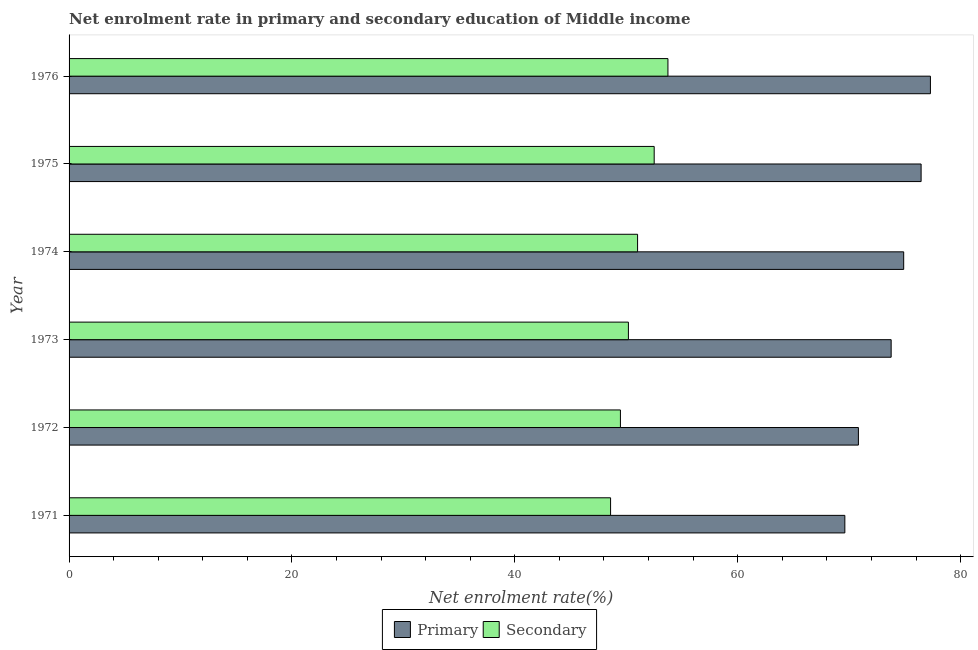How many different coloured bars are there?
Keep it short and to the point. 2. Are the number of bars per tick equal to the number of legend labels?
Your answer should be very brief. Yes. Are the number of bars on each tick of the Y-axis equal?
Provide a short and direct response. Yes. How many bars are there on the 2nd tick from the bottom?
Keep it short and to the point. 2. What is the label of the 3rd group of bars from the top?
Offer a very short reply. 1974. In how many cases, is the number of bars for a given year not equal to the number of legend labels?
Make the answer very short. 0. What is the enrollment rate in secondary education in 1971?
Ensure brevity in your answer.  48.59. Across all years, what is the maximum enrollment rate in secondary education?
Your response must be concise. 53.74. Across all years, what is the minimum enrollment rate in primary education?
Your answer should be very brief. 69.61. In which year was the enrollment rate in primary education maximum?
Give a very brief answer. 1976. What is the total enrollment rate in secondary education in the graph?
Offer a very short reply. 305.52. What is the difference between the enrollment rate in primary education in 1974 and that in 1975?
Offer a terse response. -1.56. What is the difference between the enrollment rate in secondary education in 1971 and the enrollment rate in primary education in 1973?
Your answer should be compact. -25.18. What is the average enrollment rate in secondary education per year?
Offer a terse response. 50.92. In the year 1976, what is the difference between the enrollment rate in secondary education and enrollment rate in primary education?
Provide a succinct answer. -23.55. In how many years, is the enrollment rate in primary education greater than 76 %?
Provide a short and direct response. 2. What is the ratio of the enrollment rate in primary education in 1971 to that in 1974?
Your response must be concise. 0.93. Is the enrollment rate in secondary education in 1975 less than that in 1976?
Offer a very short reply. Yes. Is the difference between the enrollment rate in primary education in 1971 and 1976 greater than the difference between the enrollment rate in secondary education in 1971 and 1976?
Your response must be concise. No. What is the difference between the highest and the second highest enrollment rate in primary education?
Offer a very short reply. 0.83. What is the difference between the highest and the lowest enrollment rate in secondary education?
Provide a succinct answer. 5.15. Is the sum of the enrollment rate in primary education in 1974 and 1976 greater than the maximum enrollment rate in secondary education across all years?
Make the answer very short. Yes. What does the 1st bar from the top in 1975 represents?
Offer a terse response. Secondary. What does the 1st bar from the bottom in 1974 represents?
Make the answer very short. Primary. Are all the bars in the graph horizontal?
Keep it short and to the point. Yes. How many years are there in the graph?
Your response must be concise. 6. Does the graph contain grids?
Make the answer very short. No. Where does the legend appear in the graph?
Your answer should be very brief. Bottom center. How many legend labels are there?
Your response must be concise. 2. What is the title of the graph?
Provide a short and direct response. Net enrolment rate in primary and secondary education of Middle income. What is the label or title of the X-axis?
Provide a succinct answer. Net enrolment rate(%). What is the Net enrolment rate(%) of Primary in 1971?
Your response must be concise. 69.61. What is the Net enrolment rate(%) of Secondary in 1971?
Provide a short and direct response. 48.59. What is the Net enrolment rate(%) of Primary in 1972?
Keep it short and to the point. 70.83. What is the Net enrolment rate(%) of Secondary in 1972?
Make the answer very short. 49.48. What is the Net enrolment rate(%) in Primary in 1973?
Offer a terse response. 73.77. What is the Net enrolment rate(%) of Secondary in 1973?
Offer a very short reply. 50.19. What is the Net enrolment rate(%) of Primary in 1974?
Your answer should be compact. 74.9. What is the Net enrolment rate(%) of Secondary in 1974?
Give a very brief answer. 51.02. What is the Net enrolment rate(%) in Primary in 1975?
Provide a succinct answer. 76.46. What is the Net enrolment rate(%) of Secondary in 1975?
Make the answer very short. 52.51. What is the Net enrolment rate(%) in Primary in 1976?
Offer a very short reply. 77.29. What is the Net enrolment rate(%) in Secondary in 1976?
Provide a short and direct response. 53.74. Across all years, what is the maximum Net enrolment rate(%) of Primary?
Provide a succinct answer. 77.29. Across all years, what is the maximum Net enrolment rate(%) in Secondary?
Your response must be concise. 53.74. Across all years, what is the minimum Net enrolment rate(%) of Primary?
Ensure brevity in your answer.  69.61. Across all years, what is the minimum Net enrolment rate(%) of Secondary?
Your answer should be very brief. 48.59. What is the total Net enrolment rate(%) of Primary in the graph?
Ensure brevity in your answer.  442.87. What is the total Net enrolment rate(%) of Secondary in the graph?
Your answer should be very brief. 305.52. What is the difference between the Net enrolment rate(%) in Primary in 1971 and that in 1972?
Ensure brevity in your answer.  -1.22. What is the difference between the Net enrolment rate(%) of Secondary in 1971 and that in 1972?
Ensure brevity in your answer.  -0.88. What is the difference between the Net enrolment rate(%) in Primary in 1971 and that in 1973?
Make the answer very short. -4.16. What is the difference between the Net enrolment rate(%) of Secondary in 1971 and that in 1973?
Make the answer very short. -1.6. What is the difference between the Net enrolment rate(%) in Primary in 1971 and that in 1974?
Offer a very short reply. -5.28. What is the difference between the Net enrolment rate(%) in Secondary in 1971 and that in 1974?
Keep it short and to the point. -2.42. What is the difference between the Net enrolment rate(%) in Primary in 1971 and that in 1975?
Give a very brief answer. -6.84. What is the difference between the Net enrolment rate(%) in Secondary in 1971 and that in 1975?
Your answer should be very brief. -3.91. What is the difference between the Net enrolment rate(%) of Primary in 1971 and that in 1976?
Provide a succinct answer. -7.68. What is the difference between the Net enrolment rate(%) of Secondary in 1971 and that in 1976?
Your answer should be very brief. -5.15. What is the difference between the Net enrolment rate(%) of Primary in 1972 and that in 1973?
Offer a very short reply. -2.94. What is the difference between the Net enrolment rate(%) in Secondary in 1972 and that in 1973?
Offer a terse response. -0.72. What is the difference between the Net enrolment rate(%) of Primary in 1972 and that in 1974?
Make the answer very short. -4.06. What is the difference between the Net enrolment rate(%) of Secondary in 1972 and that in 1974?
Provide a succinct answer. -1.54. What is the difference between the Net enrolment rate(%) of Primary in 1972 and that in 1975?
Your answer should be very brief. -5.63. What is the difference between the Net enrolment rate(%) in Secondary in 1972 and that in 1975?
Offer a terse response. -3.03. What is the difference between the Net enrolment rate(%) of Primary in 1972 and that in 1976?
Give a very brief answer. -6.46. What is the difference between the Net enrolment rate(%) in Secondary in 1972 and that in 1976?
Offer a terse response. -4.26. What is the difference between the Net enrolment rate(%) in Primary in 1973 and that in 1974?
Provide a succinct answer. -1.12. What is the difference between the Net enrolment rate(%) of Secondary in 1973 and that in 1974?
Provide a short and direct response. -0.82. What is the difference between the Net enrolment rate(%) in Primary in 1973 and that in 1975?
Ensure brevity in your answer.  -2.69. What is the difference between the Net enrolment rate(%) in Secondary in 1973 and that in 1975?
Ensure brevity in your answer.  -2.31. What is the difference between the Net enrolment rate(%) in Primary in 1973 and that in 1976?
Give a very brief answer. -3.52. What is the difference between the Net enrolment rate(%) in Secondary in 1973 and that in 1976?
Provide a succinct answer. -3.55. What is the difference between the Net enrolment rate(%) of Primary in 1974 and that in 1975?
Your response must be concise. -1.56. What is the difference between the Net enrolment rate(%) in Secondary in 1974 and that in 1975?
Keep it short and to the point. -1.49. What is the difference between the Net enrolment rate(%) of Primary in 1974 and that in 1976?
Make the answer very short. -2.4. What is the difference between the Net enrolment rate(%) of Secondary in 1974 and that in 1976?
Offer a terse response. -2.72. What is the difference between the Net enrolment rate(%) in Primary in 1975 and that in 1976?
Your answer should be compact. -0.84. What is the difference between the Net enrolment rate(%) of Secondary in 1975 and that in 1976?
Offer a terse response. -1.23. What is the difference between the Net enrolment rate(%) of Primary in 1971 and the Net enrolment rate(%) of Secondary in 1972?
Your response must be concise. 20.14. What is the difference between the Net enrolment rate(%) in Primary in 1971 and the Net enrolment rate(%) in Secondary in 1973?
Offer a very short reply. 19.42. What is the difference between the Net enrolment rate(%) in Primary in 1971 and the Net enrolment rate(%) in Secondary in 1974?
Offer a terse response. 18.6. What is the difference between the Net enrolment rate(%) of Primary in 1971 and the Net enrolment rate(%) of Secondary in 1975?
Ensure brevity in your answer.  17.11. What is the difference between the Net enrolment rate(%) in Primary in 1971 and the Net enrolment rate(%) in Secondary in 1976?
Your answer should be very brief. 15.88. What is the difference between the Net enrolment rate(%) of Primary in 1972 and the Net enrolment rate(%) of Secondary in 1973?
Your answer should be compact. 20.64. What is the difference between the Net enrolment rate(%) in Primary in 1972 and the Net enrolment rate(%) in Secondary in 1974?
Your answer should be very brief. 19.82. What is the difference between the Net enrolment rate(%) of Primary in 1972 and the Net enrolment rate(%) of Secondary in 1975?
Keep it short and to the point. 18.33. What is the difference between the Net enrolment rate(%) of Primary in 1972 and the Net enrolment rate(%) of Secondary in 1976?
Your answer should be compact. 17.09. What is the difference between the Net enrolment rate(%) in Primary in 1973 and the Net enrolment rate(%) in Secondary in 1974?
Your answer should be compact. 22.76. What is the difference between the Net enrolment rate(%) in Primary in 1973 and the Net enrolment rate(%) in Secondary in 1975?
Make the answer very short. 21.27. What is the difference between the Net enrolment rate(%) in Primary in 1973 and the Net enrolment rate(%) in Secondary in 1976?
Keep it short and to the point. 20.03. What is the difference between the Net enrolment rate(%) in Primary in 1974 and the Net enrolment rate(%) in Secondary in 1975?
Offer a terse response. 22.39. What is the difference between the Net enrolment rate(%) of Primary in 1974 and the Net enrolment rate(%) of Secondary in 1976?
Give a very brief answer. 21.16. What is the difference between the Net enrolment rate(%) in Primary in 1975 and the Net enrolment rate(%) in Secondary in 1976?
Ensure brevity in your answer.  22.72. What is the average Net enrolment rate(%) of Primary per year?
Provide a short and direct response. 73.81. What is the average Net enrolment rate(%) of Secondary per year?
Your answer should be very brief. 50.92. In the year 1971, what is the difference between the Net enrolment rate(%) of Primary and Net enrolment rate(%) of Secondary?
Make the answer very short. 21.02. In the year 1972, what is the difference between the Net enrolment rate(%) of Primary and Net enrolment rate(%) of Secondary?
Your response must be concise. 21.36. In the year 1973, what is the difference between the Net enrolment rate(%) in Primary and Net enrolment rate(%) in Secondary?
Provide a succinct answer. 23.58. In the year 1974, what is the difference between the Net enrolment rate(%) in Primary and Net enrolment rate(%) in Secondary?
Your response must be concise. 23.88. In the year 1975, what is the difference between the Net enrolment rate(%) in Primary and Net enrolment rate(%) in Secondary?
Provide a short and direct response. 23.95. In the year 1976, what is the difference between the Net enrolment rate(%) in Primary and Net enrolment rate(%) in Secondary?
Your answer should be compact. 23.55. What is the ratio of the Net enrolment rate(%) of Primary in 1971 to that in 1972?
Keep it short and to the point. 0.98. What is the ratio of the Net enrolment rate(%) in Secondary in 1971 to that in 1972?
Make the answer very short. 0.98. What is the ratio of the Net enrolment rate(%) of Primary in 1971 to that in 1973?
Keep it short and to the point. 0.94. What is the ratio of the Net enrolment rate(%) in Secondary in 1971 to that in 1973?
Provide a succinct answer. 0.97. What is the ratio of the Net enrolment rate(%) in Primary in 1971 to that in 1974?
Provide a short and direct response. 0.93. What is the ratio of the Net enrolment rate(%) in Secondary in 1971 to that in 1974?
Your response must be concise. 0.95. What is the ratio of the Net enrolment rate(%) in Primary in 1971 to that in 1975?
Keep it short and to the point. 0.91. What is the ratio of the Net enrolment rate(%) of Secondary in 1971 to that in 1975?
Offer a very short reply. 0.93. What is the ratio of the Net enrolment rate(%) of Primary in 1971 to that in 1976?
Provide a succinct answer. 0.9. What is the ratio of the Net enrolment rate(%) of Secondary in 1971 to that in 1976?
Offer a very short reply. 0.9. What is the ratio of the Net enrolment rate(%) of Primary in 1972 to that in 1973?
Provide a succinct answer. 0.96. What is the ratio of the Net enrolment rate(%) in Secondary in 1972 to that in 1973?
Offer a terse response. 0.99. What is the ratio of the Net enrolment rate(%) of Primary in 1972 to that in 1974?
Ensure brevity in your answer.  0.95. What is the ratio of the Net enrolment rate(%) of Secondary in 1972 to that in 1974?
Keep it short and to the point. 0.97. What is the ratio of the Net enrolment rate(%) in Primary in 1972 to that in 1975?
Provide a succinct answer. 0.93. What is the ratio of the Net enrolment rate(%) in Secondary in 1972 to that in 1975?
Keep it short and to the point. 0.94. What is the ratio of the Net enrolment rate(%) in Primary in 1972 to that in 1976?
Make the answer very short. 0.92. What is the ratio of the Net enrolment rate(%) of Secondary in 1972 to that in 1976?
Ensure brevity in your answer.  0.92. What is the ratio of the Net enrolment rate(%) of Primary in 1973 to that in 1974?
Offer a very short reply. 0.98. What is the ratio of the Net enrolment rate(%) in Secondary in 1973 to that in 1974?
Keep it short and to the point. 0.98. What is the ratio of the Net enrolment rate(%) in Primary in 1973 to that in 1975?
Provide a succinct answer. 0.96. What is the ratio of the Net enrolment rate(%) in Secondary in 1973 to that in 1975?
Keep it short and to the point. 0.96. What is the ratio of the Net enrolment rate(%) in Primary in 1973 to that in 1976?
Ensure brevity in your answer.  0.95. What is the ratio of the Net enrolment rate(%) in Secondary in 1973 to that in 1976?
Make the answer very short. 0.93. What is the ratio of the Net enrolment rate(%) of Primary in 1974 to that in 1975?
Provide a succinct answer. 0.98. What is the ratio of the Net enrolment rate(%) in Secondary in 1974 to that in 1975?
Provide a short and direct response. 0.97. What is the ratio of the Net enrolment rate(%) of Secondary in 1974 to that in 1976?
Provide a succinct answer. 0.95. What is the ratio of the Net enrolment rate(%) in Primary in 1975 to that in 1976?
Your response must be concise. 0.99. What is the ratio of the Net enrolment rate(%) in Secondary in 1975 to that in 1976?
Provide a short and direct response. 0.98. What is the difference between the highest and the second highest Net enrolment rate(%) of Primary?
Keep it short and to the point. 0.84. What is the difference between the highest and the second highest Net enrolment rate(%) of Secondary?
Provide a short and direct response. 1.23. What is the difference between the highest and the lowest Net enrolment rate(%) of Primary?
Your answer should be compact. 7.68. What is the difference between the highest and the lowest Net enrolment rate(%) in Secondary?
Provide a short and direct response. 5.15. 